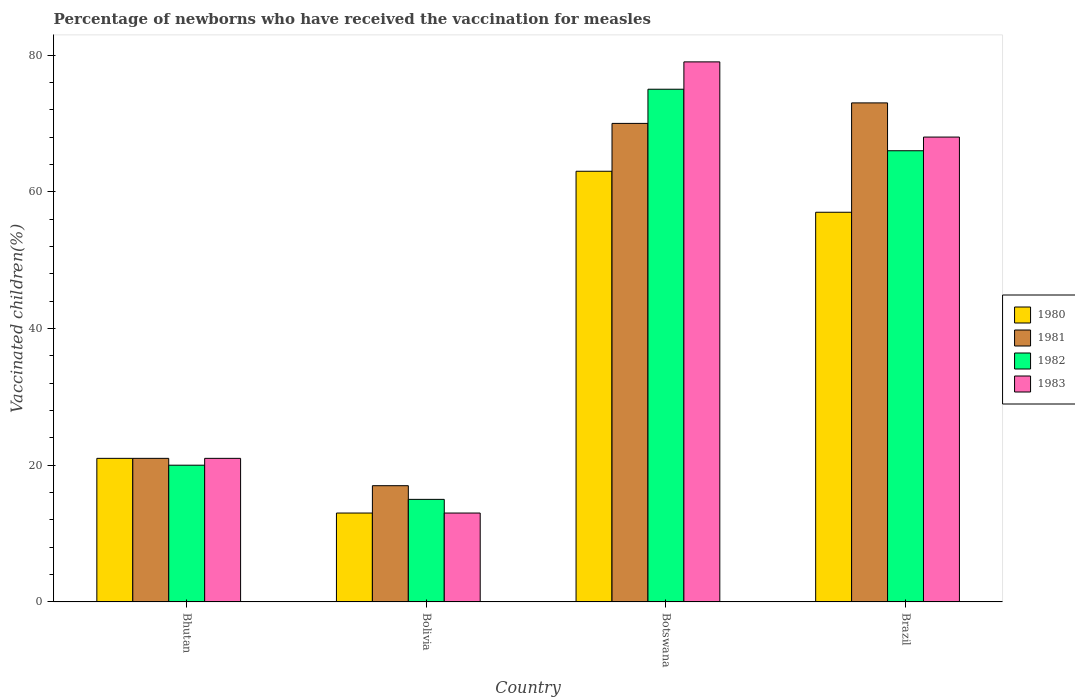How many different coloured bars are there?
Your answer should be compact. 4. Are the number of bars per tick equal to the number of legend labels?
Give a very brief answer. Yes. How many bars are there on the 1st tick from the left?
Provide a short and direct response. 4. How many bars are there on the 4th tick from the right?
Your answer should be very brief. 4. What is the label of the 3rd group of bars from the left?
Your answer should be compact. Botswana. In how many cases, is the number of bars for a given country not equal to the number of legend labels?
Your answer should be very brief. 0. Across all countries, what is the maximum percentage of vaccinated children in 1983?
Ensure brevity in your answer.  79. Across all countries, what is the minimum percentage of vaccinated children in 1982?
Keep it short and to the point. 15. In which country was the percentage of vaccinated children in 1980 maximum?
Make the answer very short. Botswana. What is the total percentage of vaccinated children in 1983 in the graph?
Give a very brief answer. 181. What is the difference between the percentage of vaccinated children in 1983 in Bolivia and that in Botswana?
Your response must be concise. -66. What is the difference between the percentage of vaccinated children in 1982 in Bhutan and the percentage of vaccinated children in 1983 in Botswana?
Make the answer very short. -59. What is the average percentage of vaccinated children in 1981 per country?
Your answer should be compact. 45.25. What is the difference between the percentage of vaccinated children of/in 1980 and percentage of vaccinated children of/in 1982 in Bhutan?
Make the answer very short. 1. What is the ratio of the percentage of vaccinated children in 1983 in Bolivia to that in Brazil?
Provide a short and direct response. 0.19. Is the difference between the percentage of vaccinated children in 1980 in Bhutan and Botswana greater than the difference between the percentage of vaccinated children in 1982 in Bhutan and Botswana?
Your response must be concise. Yes. What is the difference between the highest and the second highest percentage of vaccinated children in 1983?
Give a very brief answer. 47. What is the difference between the highest and the lowest percentage of vaccinated children in 1980?
Provide a succinct answer. 50. In how many countries, is the percentage of vaccinated children in 1983 greater than the average percentage of vaccinated children in 1983 taken over all countries?
Make the answer very short. 2. Is the sum of the percentage of vaccinated children in 1983 in Botswana and Brazil greater than the maximum percentage of vaccinated children in 1980 across all countries?
Offer a terse response. Yes. Is it the case that in every country, the sum of the percentage of vaccinated children in 1980 and percentage of vaccinated children in 1981 is greater than the sum of percentage of vaccinated children in 1983 and percentage of vaccinated children in 1982?
Give a very brief answer. No. What does the 2nd bar from the right in Bolivia represents?
Offer a very short reply. 1982. Is it the case that in every country, the sum of the percentage of vaccinated children in 1982 and percentage of vaccinated children in 1981 is greater than the percentage of vaccinated children in 1980?
Keep it short and to the point. Yes. How many bars are there?
Make the answer very short. 16. How many legend labels are there?
Your answer should be compact. 4. How are the legend labels stacked?
Your response must be concise. Vertical. What is the title of the graph?
Your answer should be compact. Percentage of newborns who have received the vaccination for measles. Does "1997" appear as one of the legend labels in the graph?
Offer a terse response. No. What is the label or title of the Y-axis?
Offer a terse response. Vaccinated children(%). What is the Vaccinated children(%) in 1982 in Bhutan?
Your answer should be very brief. 20. What is the Vaccinated children(%) of 1983 in Bhutan?
Give a very brief answer. 21. What is the Vaccinated children(%) in 1983 in Bolivia?
Offer a terse response. 13. What is the Vaccinated children(%) in 1980 in Botswana?
Ensure brevity in your answer.  63. What is the Vaccinated children(%) in 1981 in Botswana?
Keep it short and to the point. 70. What is the Vaccinated children(%) of 1983 in Botswana?
Keep it short and to the point. 79. What is the Vaccinated children(%) of 1981 in Brazil?
Make the answer very short. 73. What is the Vaccinated children(%) of 1982 in Brazil?
Make the answer very short. 66. Across all countries, what is the maximum Vaccinated children(%) of 1983?
Offer a very short reply. 79. Across all countries, what is the minimum Vaccinated children(%) in 1982?
Give a very brief answer. 15. What is the total Vaccinated children(%) of 1980 in the graph?
Provide a succinct answer. 154. What is the total Vaccinated children(%) in 1981 in the graph?
Your response must be concise. 181. What is the total Vaccinated children(%) in 1982 in the graph?
Your response must be concise. 176. What is the total Vaccinated children(%) of 1983 in the graph?
Offer a terse response. 181. What is the difference between the Vaccinated children(%) of 1980 in Bhutan and that in Bolivia?
Your answer should be very brief. 8. What is the difference between the Vaccinated children(%) of 1981 in Bhutan and that in Bolivia?
Offer a very short reply. 4. What is the difference between the Vaccinated children(%) of 1983 in Bhutan and that in Bolivia?
Make the answer very short. 8. What is the difference between the Vaccinated children(%) in 1980 in Bhutan and that in Botswana?
Your answer should be compact. -42. What is the difference between the Vaccinated children(%) of 1981 in Bhutan and that in Botswana?
Provide a succinct answer. -49. What is the difference between the Vaccinated children(%) in 1982 in Bhutan and that in Botswana?
Keep it short and to the point. -55. What is the difference between the Vaccinated children(%) in 1983 in Bhutan and that in Botswana?
Offer a very short reply. -58. What is the difference between the Vaccinated children(%) of 1980 in Bhutan and that in Brazil?
Your answer should be compact. -36. What is the difference between the Vaccinated children(%) in 1981 in Bhutan and that in Brazil?
Offer a terse response. -52. What is the difference between the Vaccinated children(%) of 1982 in Bhutan and that in Brazil?
Give a very brief answer. -46. What is the difference between the Vaccinated children(%) of 1983 in Bhutan and that in Brazil?
Ensure brevity in your answer.  -47. What is the difference between the Vaccinated children(%) of 1980 in Bolivia and that in Botswana?
Your response must be concise. -50. What is the difference between the Vaccinated children(%) of 1981 in Bolivia and that in Botswana?
Keep it short and to the point. -53. What is the difference between the Vaccinated children(%) in 1982 in Bolivia and that in Botswana?
Offer a very short reply. -60. What is the difference between the Vaccinated children(%) in 1983 in Bolivia and that in Botswana?
Your answer should be very brief. -66. What is the difference between the Vaccinated children(%) in 1980 in Bolivia and that in Brazil?
Provide a short and direct response. -44. What is the difference between the Vaccinated children(%) of 1981 in Bolivia and that in Brazil?
Make the answer very short. -56. What is the difference between the Vaccinated children(%) of 1982 in Bolivia and that in Brazil?
Offer a very short reply. -51. What is the difference between the Vaccinated children(%) in 1983 in Bolivia and that in Brazil?
Provide a succinct answer. -55. What is the difference between the Vaccinated children(%) of 1980 in Botswana and that in Brazil?
Your answer should be very brief. 6. What is the difference between the Vaccinated children(%) in 1982 in Botswana and that in Brazil?
Offer a terse response. 9. What is the difference between the Vaccinated children(%) of 1983 in Botswana and that in Brazil?
Your answer should be compact. 11. What is the difference between the Vaccinated children(%) of 1980 in Bhutan and the Vaccinated children(%) of 1982 in Bolivia?
Provide a short and direct response. 6. What is the difference between the Vaccinated children(%) of 1980 in Bhutan and the Vaccinated children(%) of 1983 in Bolivia?
Offer a very short reply. 8. What is the difference between the Vaccinated children(%) in 1980 in Bhutan and the Vaccinated children(%) in 1981 in Botswana?
Offer a terse response. -49. What is the difference between the Vaccinated children(%) of 1980 in Bhutan and the Vaccinated children(%) of 1982 in Botswana?
Give a very brief answer. -54. What is the difference between the Vaccinated children(%) of 1980 in Bhutan and the Vaccinated children(%) of 1983 in Botswana?
Your answer should be compact. -58. What is the difference between the Vaccinated children(%) of 1981 in Bhutan and the Vaccinated children(%) of 1982 in Botswana?
Provide a short and direct response. -54. What is the difference between the Vaccinated children(%) in 1981 in Bhutan and the Vaccinated children(%) in 1983 in Botswana?
Ensure brevity in your answer.  -58. What is the difference between the Vaccinated children(%) of 1982 in Bhutan and the Vaccinated children(%) of 1983 in Botswana?
Provide a succinct answer. -59. What is the difference between the Vaccinated children(%) in 1980 in Bhutan and the Vaccinated children(%) in 1981 in Brazil?
Provide a succinct answer. -52. What is the difference between the Vaccinated children(%) of 1980 in Bhutan and the Vaccinated children(%) of 1982 in Brazil?
Keep it short and to the point. -45. What is the difference between the Vaccinated children(%) in 1980 in Bhutan and the Vaccinated children(%) in 1983 in Brazil?
Give a very brief answer. -47. What is the difference between the Vaccinated children(%) in 1981 in Bhutan and the Vaccinated children(%) in 1982 in Brazil?
Ensure brevity in your answer.  -45. What is the difference between the Vaccinated children(%) of 1981 in Bhutan and the Vaccinated children(%) of 1983 in Brazil?
Your answer should be very brief. -47. What is the difference between the Vaccinated children(%) of 1982 in Bhutan and the Vaccinated children(%) of 1983 in Brazil?
Provide a short and direct response. -48. What is the difference between the Vaccinated children(%) of 1980 in Bolivia and the Vaccinated children(%) of 1981 in Botswana?
Ensure brevity in your answer.  -57. What is the difference between the Vaccinated children(%) of 1980 in Bolivia and the Vaccinated children(%) of 1982 in Botswana?
Ensure brevity in your answer.  -62. What is the difference between the Vaccinated children(%) of 1980 in Bolivia and the Vaccinated children(%) of 1983 in Botswana?
Make the answer very short. -66. What is the difference between the Vaccinated children(%) in 1981 in Bolivia and the Vaccinated children(%) in 1982 in Botswana?
Offer a very short reply. -58. What is the difference between the Vaccinated children(%) in 1981 in Bolivia and the Vaccinated children(%) in 1983 in Botswana?
Your answer should be compact. -62. What is the difference between the Vaccinated children(%) in 1982 in Bolivia and the Vaccinated children(%) in 1983 in Botswana?
Provide a short and direct response. -64. What is the difference between the Vaccinated children(%) in 1980 in Bolivia and the Vaccinated children(%) in 1981 in Brazil?
Your response must be concise. -60. What is the difference between the Vaccinated children(%) of 1980 in Bolivia and the Vaccinated children(%) of 1982 in Brazil?
Make the answer very short. -53. What is the difference between the Vaccinated children(%) in 1980 in Bolivia and the Vaccinated children(%) in 1983 in Brazil?
Keep it short and to the point. -55. What is the difference between the Vaccinated children(%) of 1981 in Bolivia and the Vaccinated children(%) of 1982 in Brazil?
Offer a very short reply. -49. What is the difference between the Vaccinated children(%) in 1981 in Bolivia and the Vaccinated children(%) in 1983 in Brazil?
Your response must be concise. -51. What is the difference between the Vaccinated children(%) of 1982 in Bolivia and the Vaccinated children(%) of 1983 in Brazil?
Your answer should be very brief. -53. What is the difference between the Vaccinated children(%) of 1980 in Botswana and the Vaccinated children(%) of 1982 in Brazil?
Your response must be concise. -3. What is the average Vaccinated children(%) in 1980 per country?
Make the answer very short. 38.5. What is the average Vaccinated children(%) of 1981 per country?
Provide a succinct answer. 45.25. What is the average Vaccinated children(%) in 1983 per country?
Give a very brief answer. 45.25. What is the difference between the Vaccinated children(%) of 1981 and Vaccinated children(%) of 1982 in Bhutan?
Your answer should be compact. 1. What is the difference between the Vaccinated children(%) in 1982 and Vaccinated children(%) in 1983 in Bhutan?
Your answer should be compact. -1. What is the difference between the Vaccinated children(%) in 1981 and Vaccinated children(%) in 1982 in Bolivia?
Make the answer very short. 2. What is the difference between the Vaccinated children(%) of 1980 and Vaccinated children(%) of 1982 in Botswana?
Offer a terse response. -12. What is the difference between the Vaccinated children(%) in 1980 and Vaccinated children(%) in 1983 in Botswana?
Your answer should be compact. -16. What is the difference between the Vaccinated children(%) of 1981 and Vaccinated children(%) of 1983 in Botswana?
Your answer should be compact. -9. What is the difference between the Vaccinated children(%) of 1980 and Vaccinated children(%) of 1981 in Brazil?
Your answer should be compact. -16. What is the difference between the Vaccinated children(%) in 1980 and Vaccinated children(%) in 1983 in Brazil?
Offer a very short reply. -11. What is the difference between the Vaccinated children(%) of 1981 and Vaccinated children(%) of 1983 in Brazil?
Offer a very short reply. 5. What is the difference between the Vaccinated children(%) in 1982 and Vaccinated children(%) in 1983 in Brazil?
Your answer should be compact. -2. What is the ratio of the Vaccinated children(%) in 1980 in Bhutan to that in Bolivia?
Keep it short and to the point. 1.62. What is the ratio of the Vaccinated children(%) of 1981 in Bhutan to that in Bolivia?
Give a very brief answer. 1.24. What is the ratio of the Vaccinated children(%) of 1982 in Bhutan to that in Bolivia?
Provide a short and direct response. 1.33. What is the ratio of the Vaccinated children(%) of 1983 in Bhutan to that in Bolivia?
Give a very brief answer. 1.62. What is the ratio of the Vaccinated children(%) in 1980 in Bhutan to that in Botswana?
Offer a very short reply. 0.33. What is the ratio of the Vaccinated children(%) of 1981 in Bhutan to that in Botswana?
Provide a short and direct response. 0.3. What is the ratio of the Vaccinated children(%) in 1982 in Bhutan to that in Botswana?
Ensure brevity in your answer.  0.27. What is the ratio of the Vaccinated children(%) in 1983 in Bhutan to that in Botswana?
Offer a very short reply. 0.27. What is the ratio of the Vaccinated children(%) of 1980 in Bhutan to that in Brazil?
Provide a short and direct response. 0.37. What is the ratio of the Vaccinated children(%) in 1981 in Bhutan to that in Brazil?
Offer a very short reply. 0.29. What is the ratio of the Vaccinated children(%) in 1982 in Bhutan to that in Brazil?
Give a very brief answer. 0.3. What is the ratio of the Vaccinated children(%) in 1983 in Bhutan to that in Brazil?
Give a very brief answer. 0.31. What is the ratio of the Vaccinated children(%) of 1980 in Bolivia to that in Botswana?
Your answer should be very brief. 0.21. What is the ratio of the Vaccinated children(%) in 1981 in Bolivia to that in Botswana?
Give a very brief answer. 0.24. What is the ratio of the Vaccinated children(%) in 1982 in Bolivia to that in Botswana?
Give a very brief answer. 0.2. What is the ratio of the Vaccinated children(%) of 1983 in Bolivia to that in Botswana?
Ensure brevity in your answer.  0.16. What is the ratio of the Vaccinated children(%) in 1980 in Bolivia to that in Brazil?
Give a very brief answer. 0.23. What is the ratio of the Vaccinated children(%) of 1981 in Bolivia to that in Brazil?
Ensure brevity in your answer.  0.23. What is the ratio of the Vaccinated children(%) in 1982 in Bolivia to that in Brazil?
Make the answer very short. 0.23. What is the ratio of the Vaccinated children(%) in 1983 in Bolivia to that in Brazil?
Provide a succinct answer. 0.19. What is the ratio of the Vaccinated children(%) in 1980 in Botswana to that in Brazil?
Make the answer very short. 1.11. What is the ratio of the Vaccinated children(%) of 1981 in Botswana to that in Brazil?
Provide a short and direct response. 0.96. What is the ratio of the Vaccinated children(%) of 1982 in Botswana to that in Brazil?
Provide a short and direct response. 1.14. What is the ratio of the Vaccinated children(%) in 1983 in Botswana to that in Brazil?
Offer a terse response. 1.16. What is the difference between the highest and the second highest Vaccinated children(%) in 1980?
Give a very brief answer. 6. What is the difference between the highest and the second highest Vaccinated children(%) of 1982?
Ensure brevity in your answer.  9. What is the difference between the highest and the second highest Vaccinated children(%) of 1983?
Make the answer very short. 11. What is the difference between the highest and the lowest Vaccinated children(%) in 1980?
Offer a very short reply. 50. 